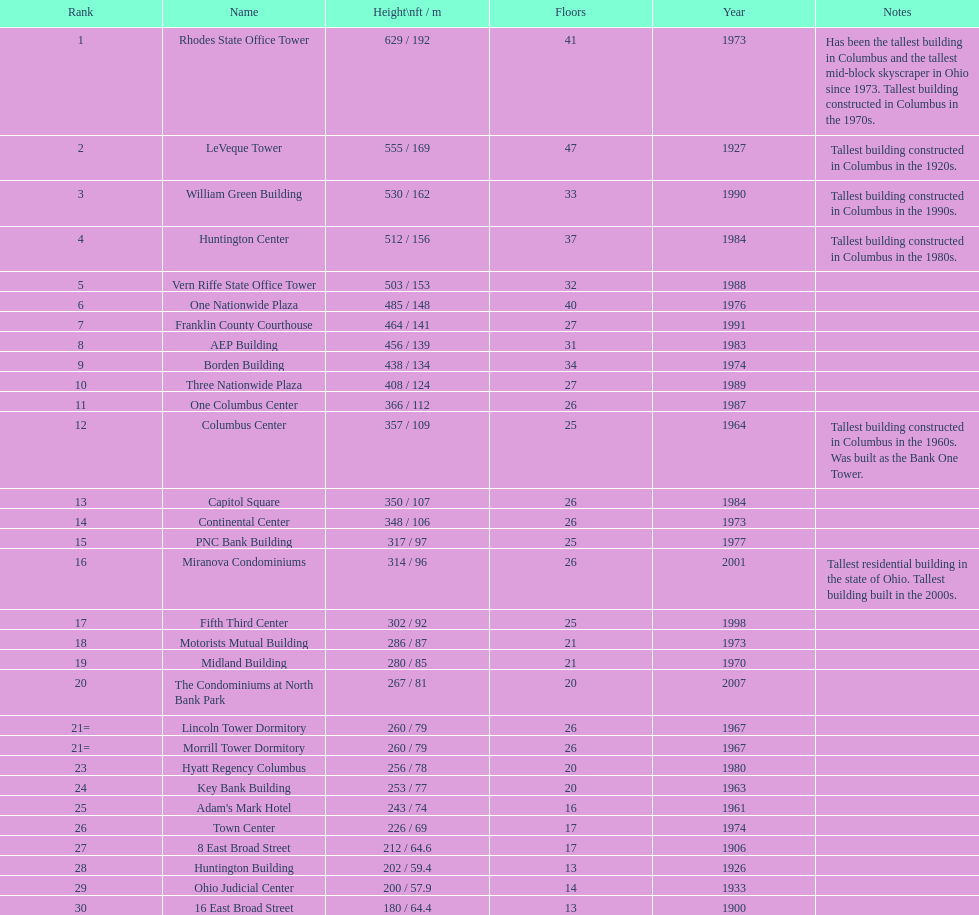Which buildings are taller than 500 ft? Rhodes State Office Tower, LeVeque Tower, William Green Building, Huntington Center, Vern Riffe State Office Tower. 